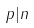<formula> <loc_0><loc_0><loc_500><loc_500>p | n</formula> 